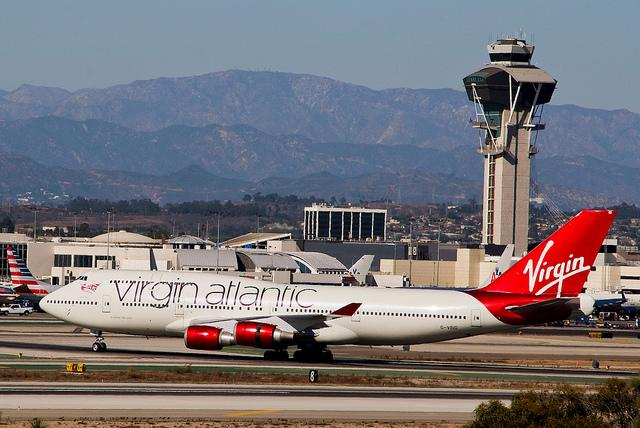Who owns the company whose name appears here? virgin 